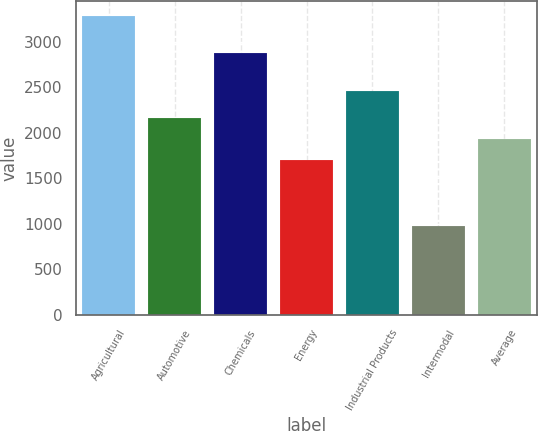Convert chart to OTSL. <chart><loc_0><loc_0><loc_500><loc_500><bar_chart><fcel>Agricultural<fcel>Automotive<fcel>Chemicals<fcel>Energy<fcel>Industrial Products<fcel>Intermodal<fcel>Average<nl><fcel>3286<fcel>2159.4<fcel>2874<fcel>1697<fcel>2461<fcel>974<fcel>1928.2<nl></chart> 